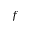Convert formula to latex. <formula><loc_0><loc_0><loc_500><loc_500>f</formula> 